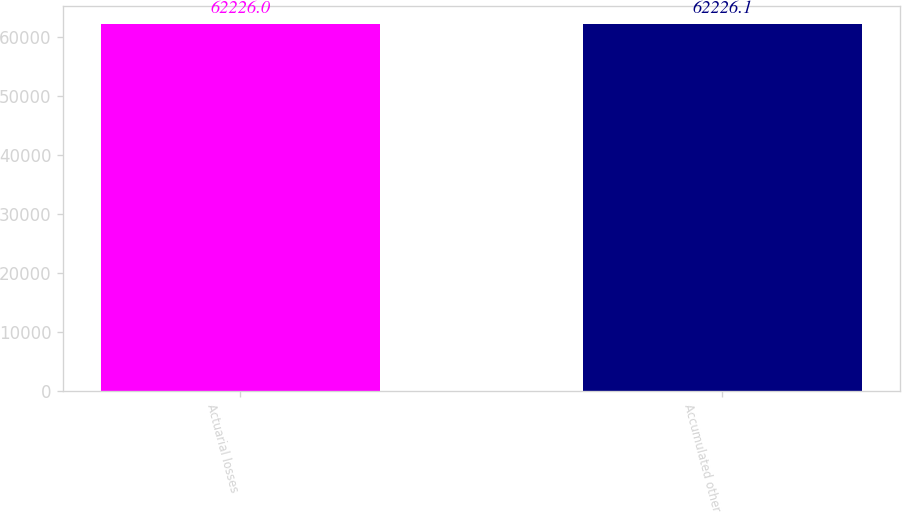Convert chart. <chart><loc_0><loc_0><loc_500><loc_500><bar_chart><fcel>Actuarial losses<fcel>Accumulated other<nl><fcel>62226<fcel>62226.1<nl></chart> 